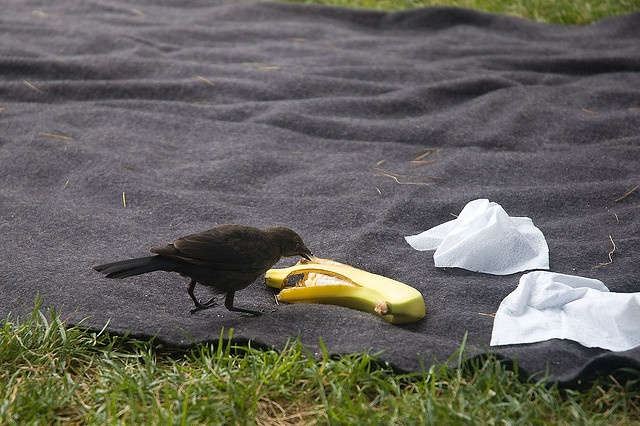Describe the objects in this image and their specific colors. I can see bird in gray and black tones and banana in gray, lightyellow, khaki, olive, and black tones in this image. 